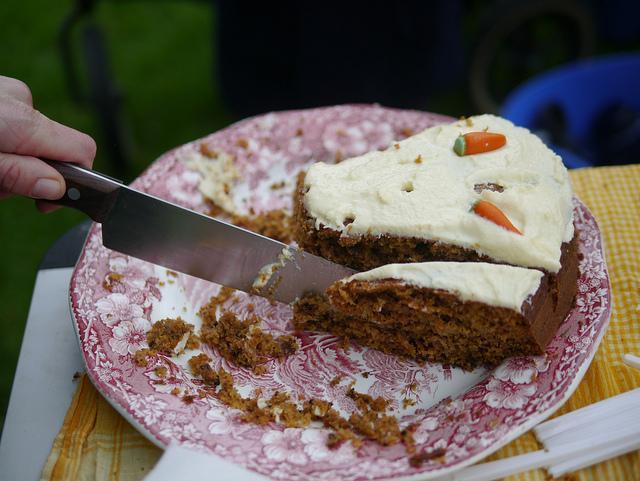Does the image validate the caption "The person is above the cake."?
Answer yes or no. No. 